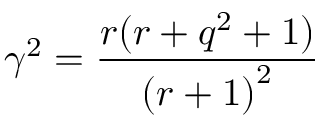Convert formula to latex. <formula><loc_0><loc_0><loc_500><loc_500>\gamma ^ { 2 } = \frac { r ( r + q ^ { 2 } + 1 ) } { { ( r + 1 ) } ^ { 2 } }</formula> 